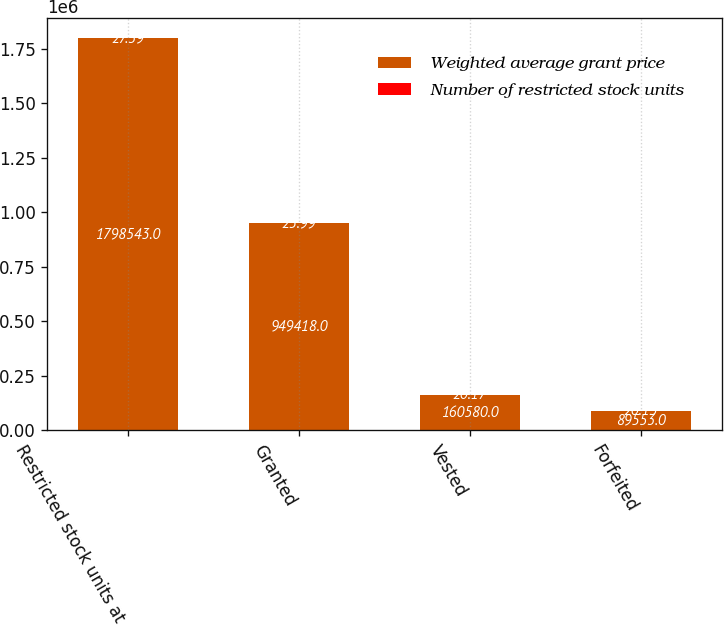Convert chart. <chart><loc_0><loc_0><loc_500><loc_500><stacked_bar_chart><ecel><fcel>Restricted stock units at<fcel>Granted<fcel>Vested<fcel>Forfeited<nl><fcel>Weighted average grant price<fcel>1.79854e+06<fcel>949418<fcel>160580<fcel>89553<nl><fcel>Number of restricted stock units<fcel>27.39<fcel>25.99<fcel>20.17<fcel>20.13<nl></chart> 